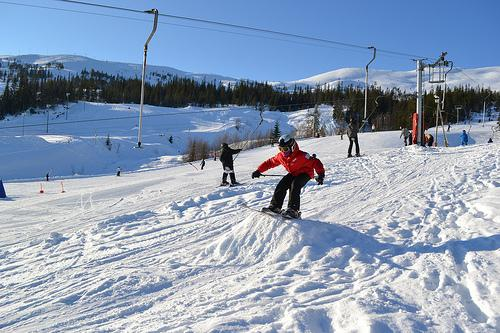List three colors that are prominent in the image. White (snow), green (evergreen trees), and blue (sky). Using adjectives, describe the appearance of the snow on the ground. The snow on the ground is white, snowy, and covered in footprints and lines. From the given captions, which person seems to be the most skilled snowboarder? The snowboarder with knees bent leaning forward on the small ramp made of snow. What type of weather does the image suggest? Clear, cold, and snowy weather. What kind of trees can be seen in the image? Evergreen trees can be seen at the edge of the slopes. Provide a brief overview of the landscape depicted in the image. The image displays a snowy park with people enjoying various snow activities, evergreen trees at the edge of the slopes, and snow-covered mountains with a clear blue sky behind them. Name two types of equipment that appear in the image related to snow activities. Snow skis and ski lifts. Describe the attire worn by the person in the center of the image. The person is wearing a red jacket, black snow pants, and a helmet. What are the mountains in the background covered with? The mountains are covered with snow. Identify the main activity happening in the image and name two objects associated with it. People are participating in snow activities; a snowboarder on a small ramp and a person hanging onto a pole can be seen. 